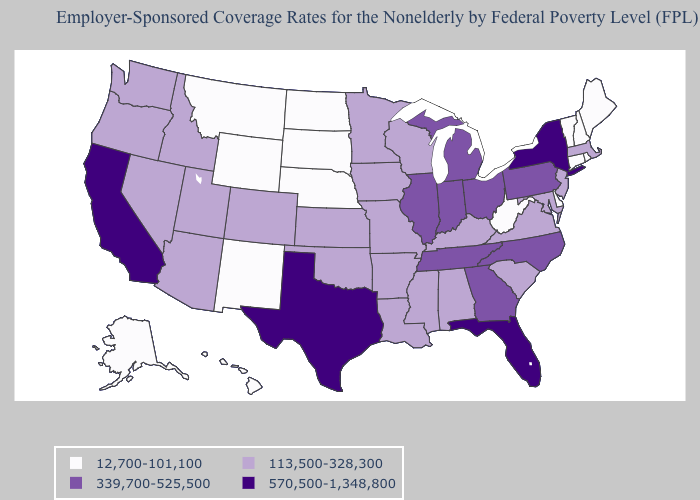What is the highest value in the USA?
Short answer required. 570,500-1,348,800. What is the lowest value in states that border Louisiana?
Write a very short answer. 113,500-328,300. What is the value of North Dakota?
Write a very short answer. 12,700-101,100. What is the value of Mississippi?
Concise answer only. 113,500-328,300. Among the states that border North Dakota , does Minnesota have the highest value?
Keep it brief. Yes. Name the states that have a value in the range 570,500-1,348,800?
Answer briefly. California, Florida, New York, Texas. What is the highest value in the USA?
Write a very short answer. 570,500-1,348,800. What is the value of New Hampshire?
Concise answer only. 12,700-101,100. Does Missouri have the lowest value in the MidWest?
Keep it brief. No. Does the first symbol in the legend represent the smallest category?
Quick response, please. Yes. What is the lowest value in the West?
Keep it brief. 12,700-101,100. Does the first symbol in the legend represent the smallest category?
Answer briefly. Yes. What is the value of Maryland?
Answer briefly. 113,500-328,300. Does Alabama have the highest value in the USA?
Short answer required. No. What is the lowest value in the South?
Short answer required. 12,700-101,100. 